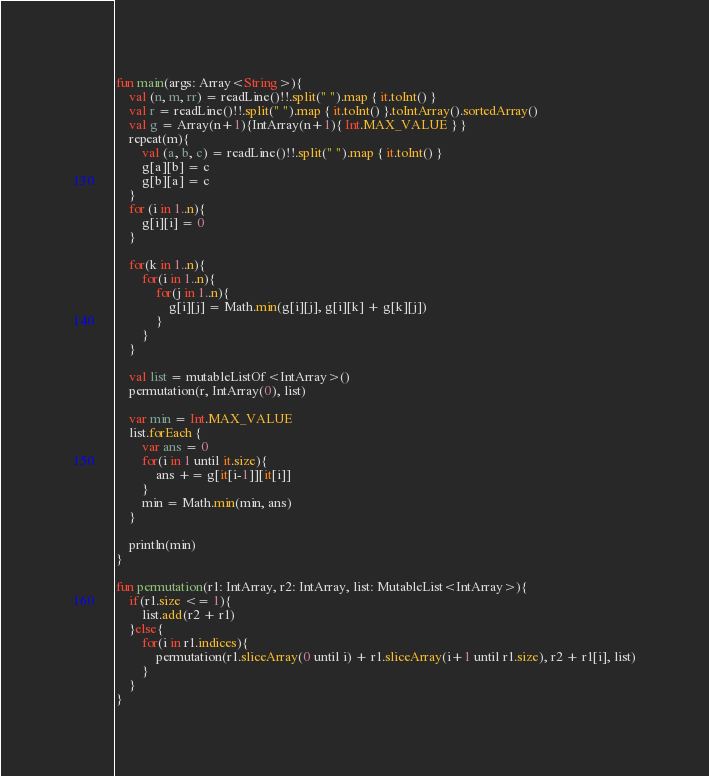Convert code to text. <code><loc_0><loc_0><loc_500><loc_500><_Kotlin_>fun main(args: Array<String>){
    val (n, m, rr) = readLine()!!.split(" ").map { it.toInt() }
    val r = readLine()!!.split(" ").map { it.toInt() }.toIntArray().sortedArray()
    val g = Array(n+1){IntArray(n+1){ Int.MAX_VALUE } }
    repeat(m){
        val (a, b, c) = readLine()!!.split(" ").map { it.toInt() }
        g[a][b] = c
        g[b][a] = c
    }
    for (i in 1..n){
        g[i][i] = 0
    }

    for(k in 1..n){
        for(i in 1..n){
            for(j in 1..n){
                g[i][j] = Math.min(g[i][j], g[i][k] + g[k][j])
            }
        }
    }

    val list = mutableListOf<IntArray>()
    permutation(r, IntArray(0), list)

    var min = Int.MAX_VALUE
    list.forEach {
        var ans = 0
        for(i in 1 until it.size){
            ans += g[it[i-1]][it[i]]
        }
        min = Math.min(min, ans)
    }

    println(min)
}

fun permutation(r1: IntArray, r2: IntArray, list: MutableList<IntArray>){
    if(r1.size <= 1){
        list.add(r2 + r1)
    }else{
        for(i in r1.indices){
            permutation(r1.sliceArray(0 until i) + r1.sliceArray(i+1 until r1.size), r2 + r1[i], list)
        }
    }
}</code> 